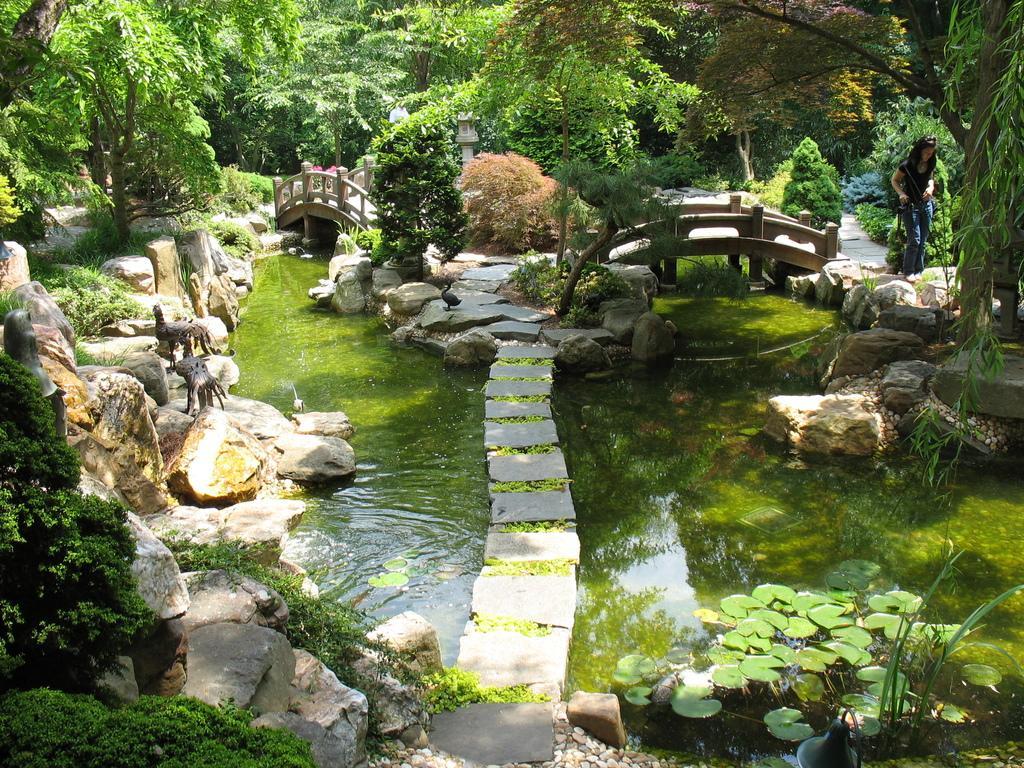Can you describe this image briefly? This is water, on the right side a beautiful woman is there and these are the mini bridges and there are green trees. 